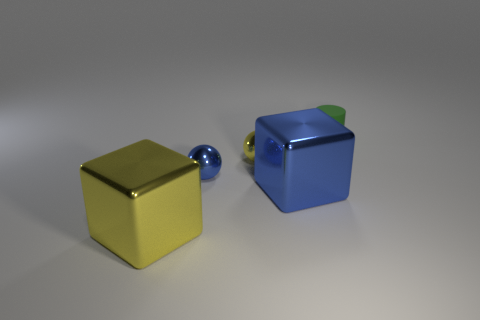Are there any things on the left side of the blue metal ball?
Make the answer very short. Yes. What number of small green rubber things are the same shape as the small blue metal object?
Your answer should be compact. 0. What is the color of the small shiny thing to the right of the blue metal object to the left of the yellow shiny thing that is to the right of the large yellow metallic thing?
Make the answer very short. Yellow. Do the cube that is to the right of the blue metal ball and the thing left of the small blue metal object have the same material?
Make the answer very short. Yes. How many objects are either things left of the tiny cylinder or large yellow metallic objects?
Keep it short and to the point. 4. How many objects are either tiny green metal cylinders or shiny things behind the tiny blue ball?
Your answer should be compact. 1. How many yellow metal spheres have the same size as the green rubber thing?
Keep it short and to the point. 1. Are there fewer cubes that are behind the tiny green matte cylinder than large metal objects right of the yellow ball?
Make the answer very short. Yes. What number of metal objects are blue blocks or blue objects?
Your answer should be very brief. 2. There is a small blue object; what shape is it?
Offer a terse response. Sphere. 